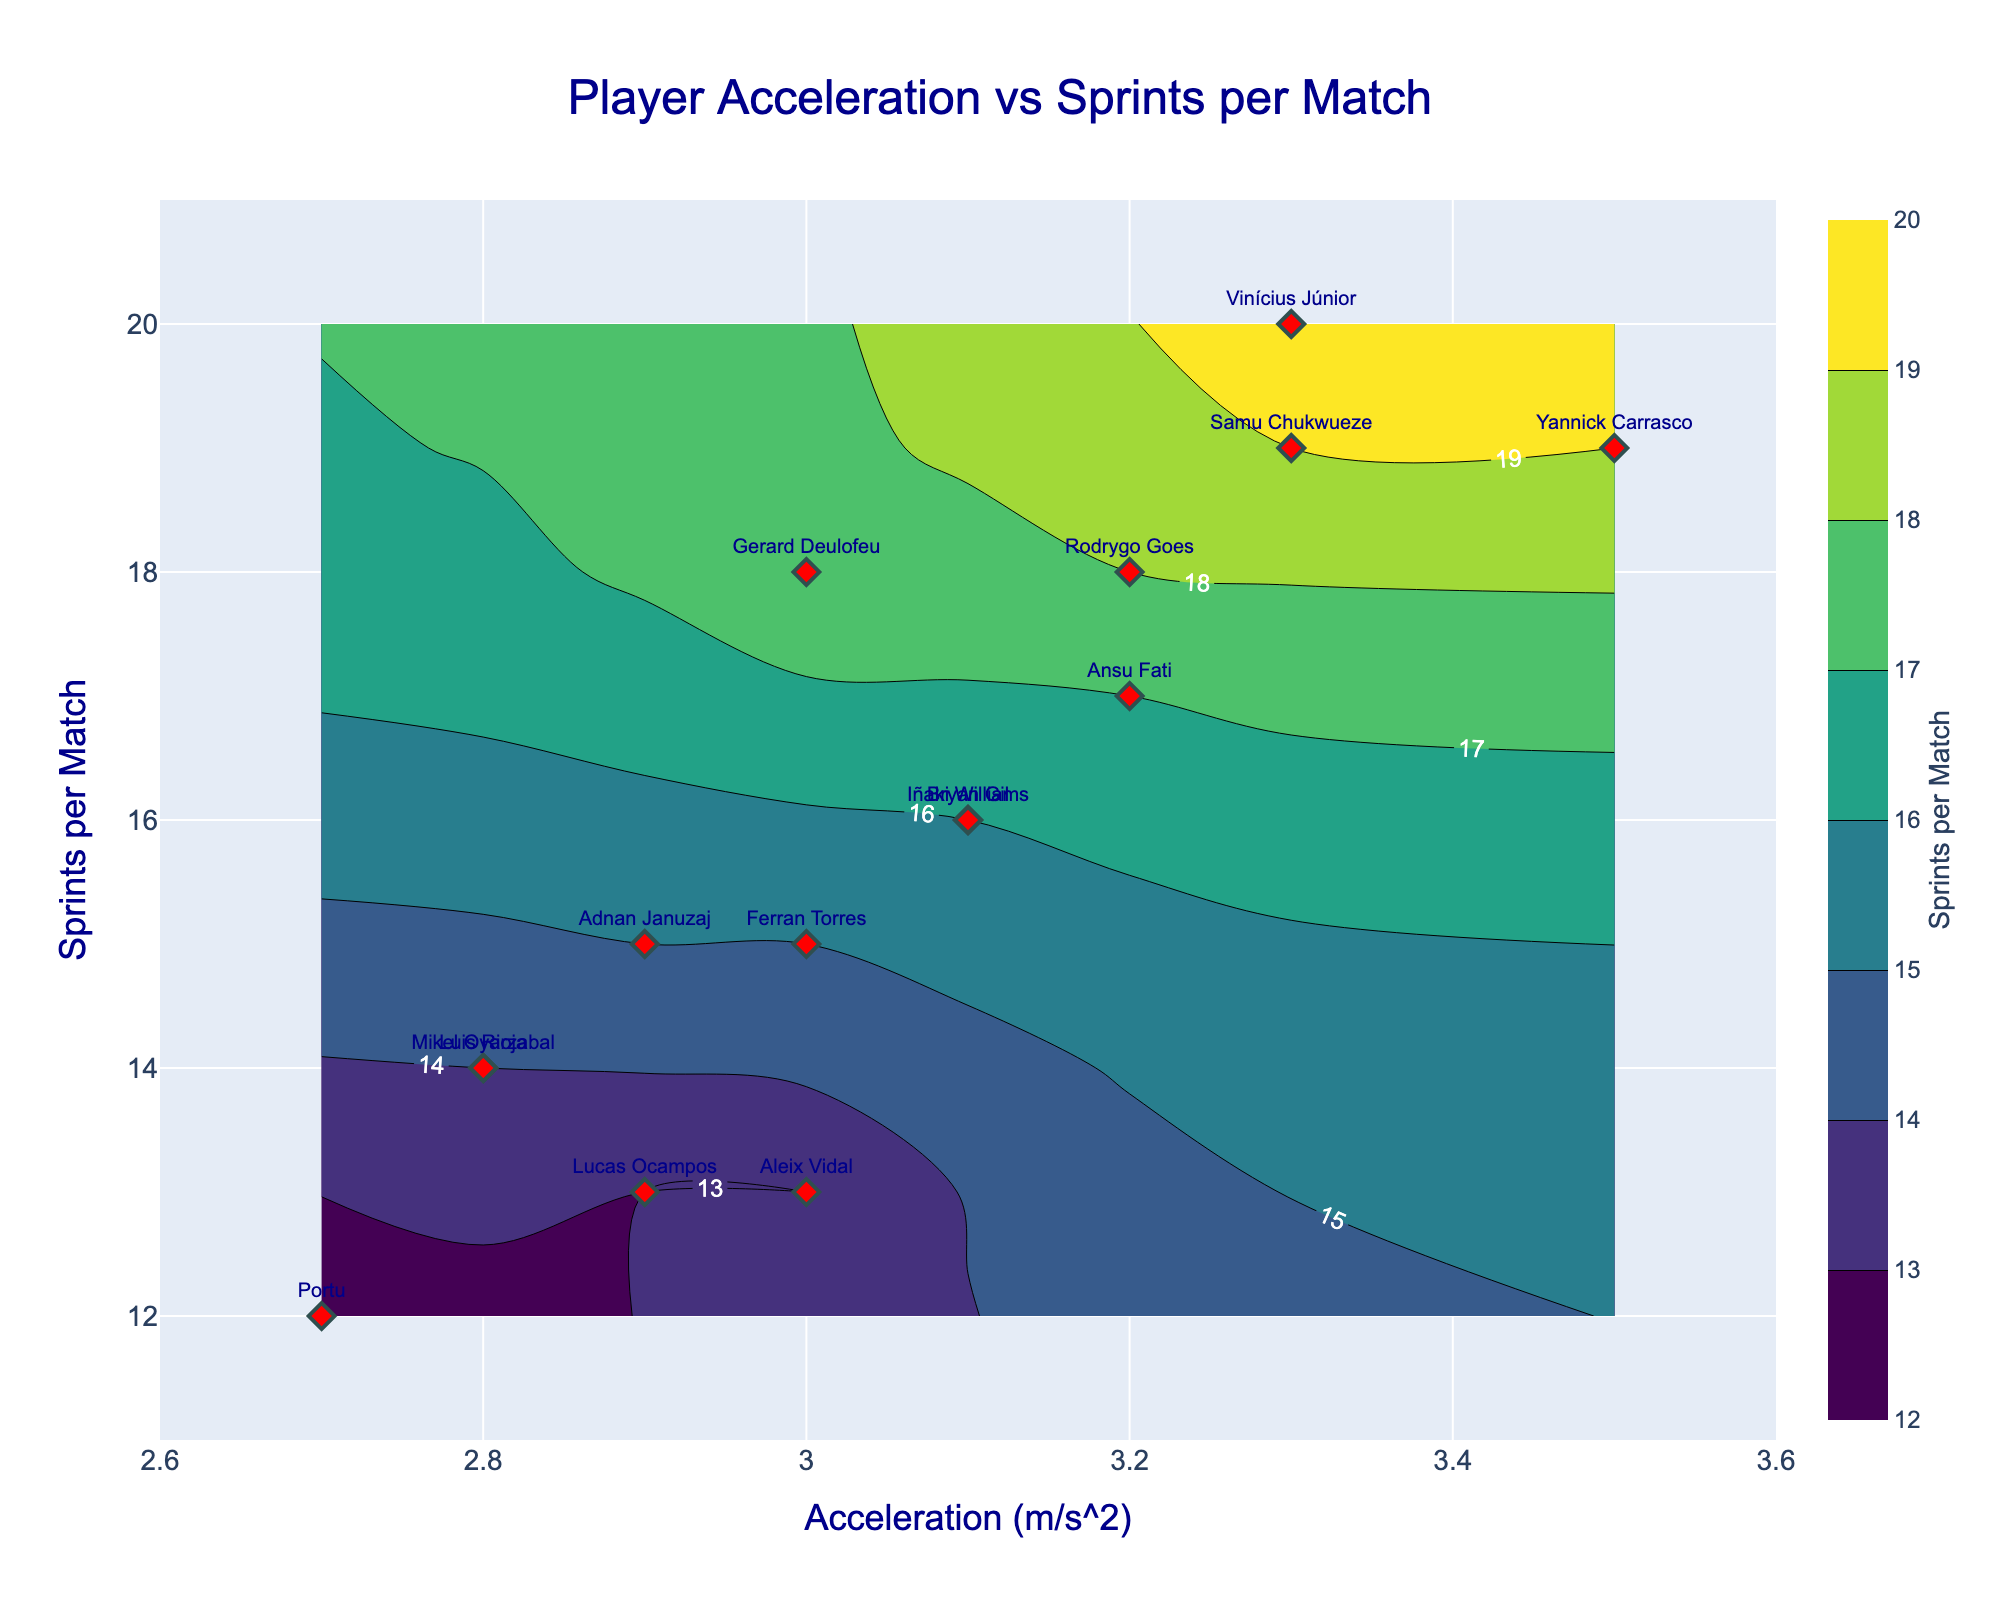How many players are represented in the plot? To determine the number of players, count all the distinct names labeled on the x-axis and y-axis of the plot.
Answer: 15 What is the general trend between acceleration and sprints per match? By observing the plot, note the distribution and direction of the points and contour lines. Points with higher acceleration tend to have more sprints per match.
Answer: Positive correlation Which player has the highest number of sprints per match? Identify the data point located at the upper boundary of the y-axis. The label at that point shows which player it is.
Answer: Vinícius Júnior Which player has the lowest acceleration? Identify the data point located at the left boundary of the x-axis. The label at that point shows which player it is.
Answer: Portu Do players with higher acceleration generally perform more sprints per match? Compare the cluster of data points and contour lines. Players positioned to the right (higher acceleration) generally have higher y-values, representing more sprints per match.
Answer: Yes Is there any player with both low acceleration and low sprints per match? Look toward the bottom-left area of the plot, identify if any data points and labels are present in this region.
Answer: Yes, Portu How does Ansu Fati's performance compare to Mikel Oyarzabal in terms of acceleration and sprints per match? Check the plot's labels to find Ansu Fati and Mikel Oyarzabal’s points. Compare both x (acceleration) and y (sprints per match) values.
Answer: Ansu Fati has higher values in both acceleration and sprints per match What is the range of acceleration covered in the plot? Identify the minimum and maximum values on the x-axis, which are given in the plot's x-axis range update.
Answer: 2.6 to 3.6 m/s² Which players have a sprint count of 19 per match? Observe the y-axis value of 19 and check the data points with labels at this y-coordinate position.
Answer: Yannick Carrasco, Samu Chukwueze What are the axis titles and plot title? Read the titles directly from the plot, which serve to label the x-axis, y-axis, and the overall plot.
Answer: "Acceleration (m/s²)", "Sprints per Match", "Player Acceleration vs Sprints per Match" 